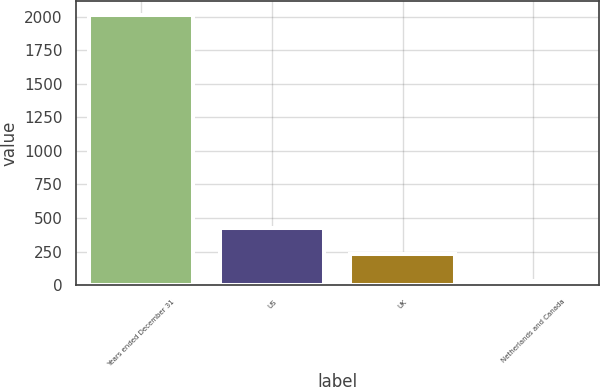<chart> <loc_0><loc_0><loc_500><loc_500><bar_chart><fcel>Years ended December 31<fcel>US<fcel>UK<fcel>Netherlands and Canada<nl><fcel>2014<fcel>426.8<fcel>228.4<fcel>30<nl></chart> 